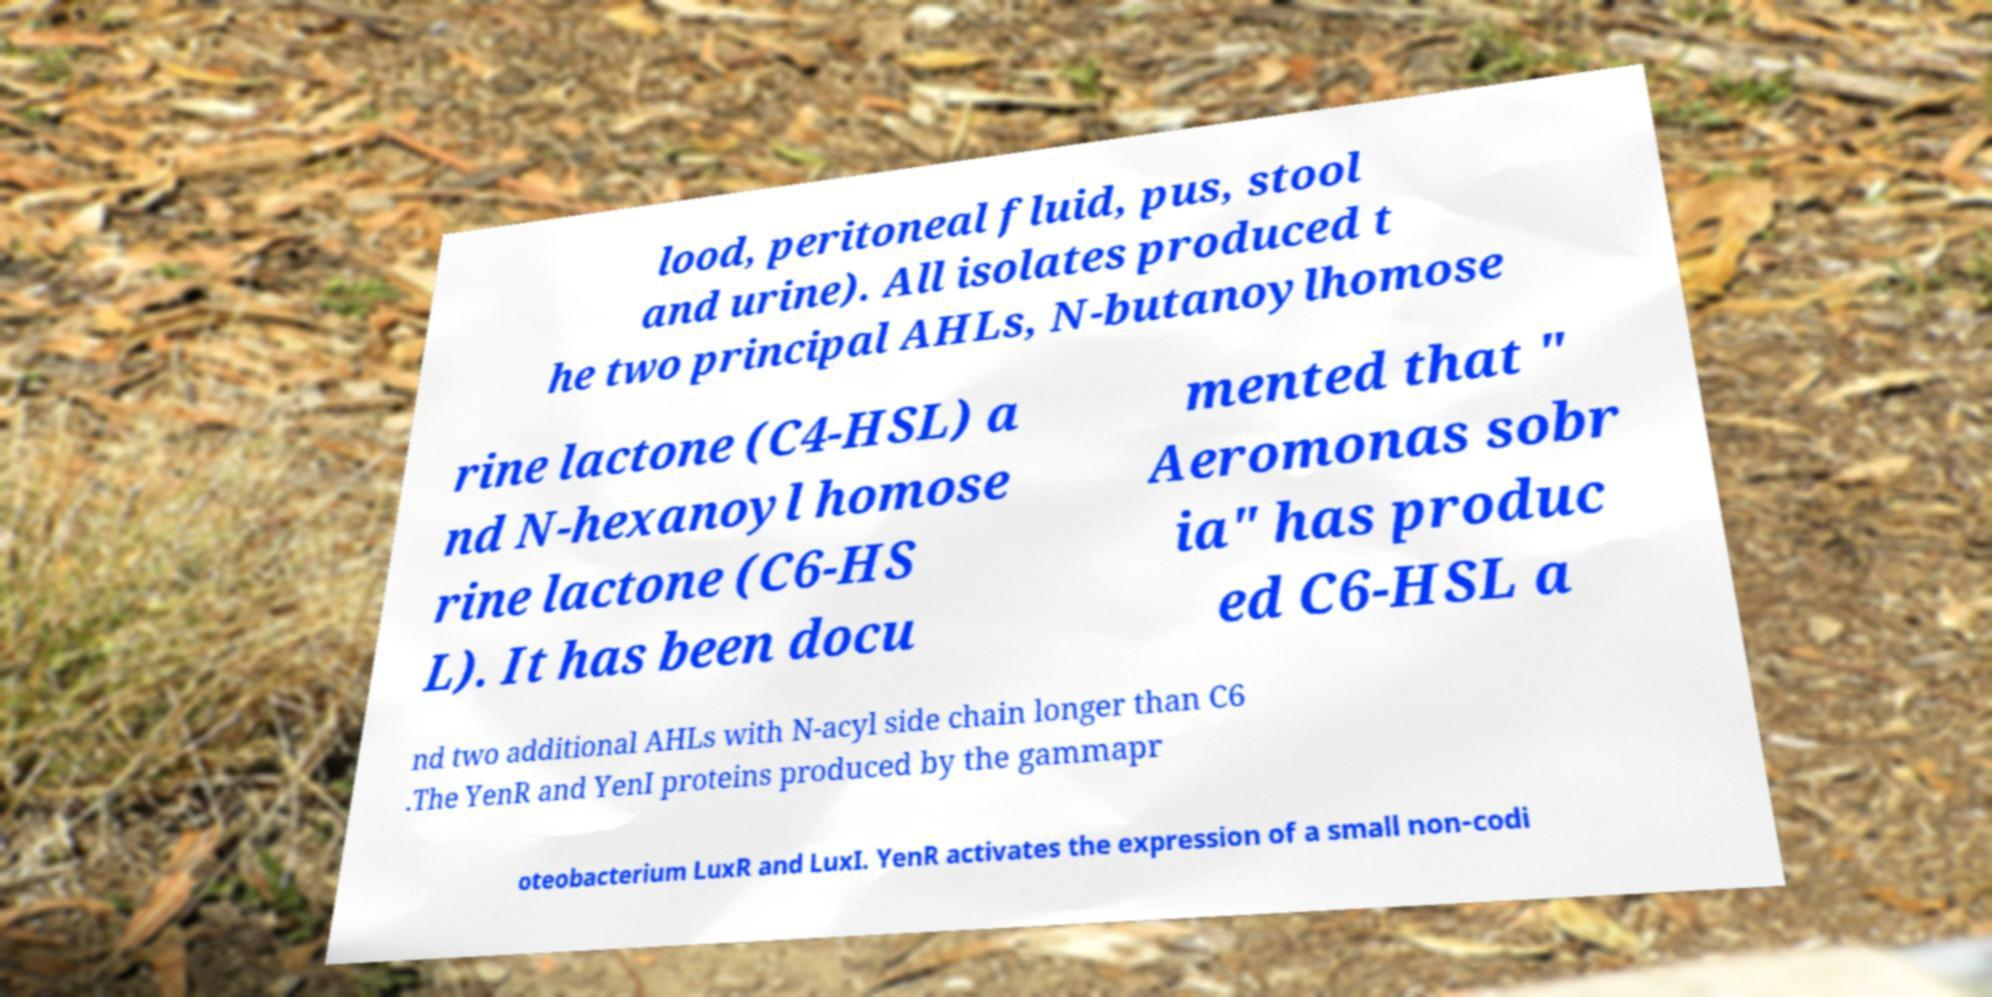What messages or text are displayed in this image? I need them in a readable, typed format. lood, peritoneal fluid, pus, stool and urine). All isolates produced t he two principal AHLs, N-butanoylhomose rine lactone (C4-HSL) a nd N-hexanoyl homose rine lactone (C6-HS L). It has been docu mented that " Aeromonas sobr ia" has produc ed C6-HSL a nd two additional AHLs with N-acyl side chain longer than C6 .The YenR and YenI proteins produced by the gammapr oteobacterium LuxR and LuxI. YenR activates the expression of a small non-codi 